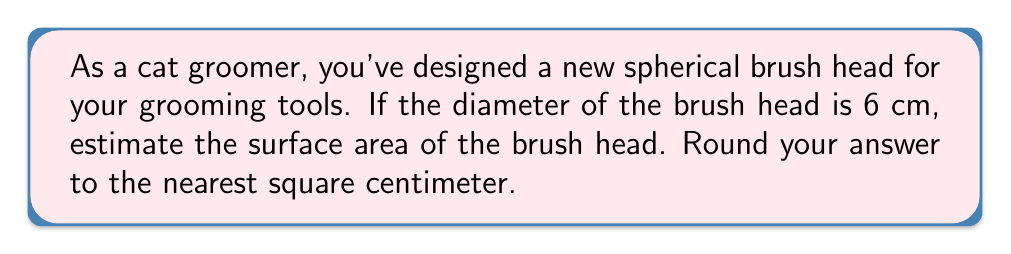Show me your answer to this math problem. To estimate the surface area of a spherical cat brush head, we'll follow these steps:

1) The formula for the surface area of a sphere is:
   $$A = 4\pi r^2$$
   where $A$ is the surface area and $r$ is the radius of the sphere.

2) We're given the diameter of 6 cm. The radius is half of the diameter:
   $$r = \frac{6}{2} = 3 \text{ cm}$$

3) Now, let's substitute this into our formula:
   $$A = 4\pi (3 \text{ cm})^2$$

4) Simplify:
   $$A = 4\pi (9 \text{ cm}^2) = 36\pi \text{ cm}^2$$

5) Calculate (using $\pi \approx 3.14159$):
   $$A \approx 36 \times 3.14159 \text{ cm}^2 \approx 113.09724 \text{ cm}^2$$

6) Rounding to the nearest square centimeter:
   $$A \approx 113 \text{ cm}^2$$

[asy]
import geometry;

size(100);
draw(circle((0,0),3), blue);
draw((-3,0)--(3,0),dashed);
label("6 cm", (0,-3.5), S);
label("r = 3 cm", (1.5,0), NE);
[/asy]
Answer: 113 cm² 